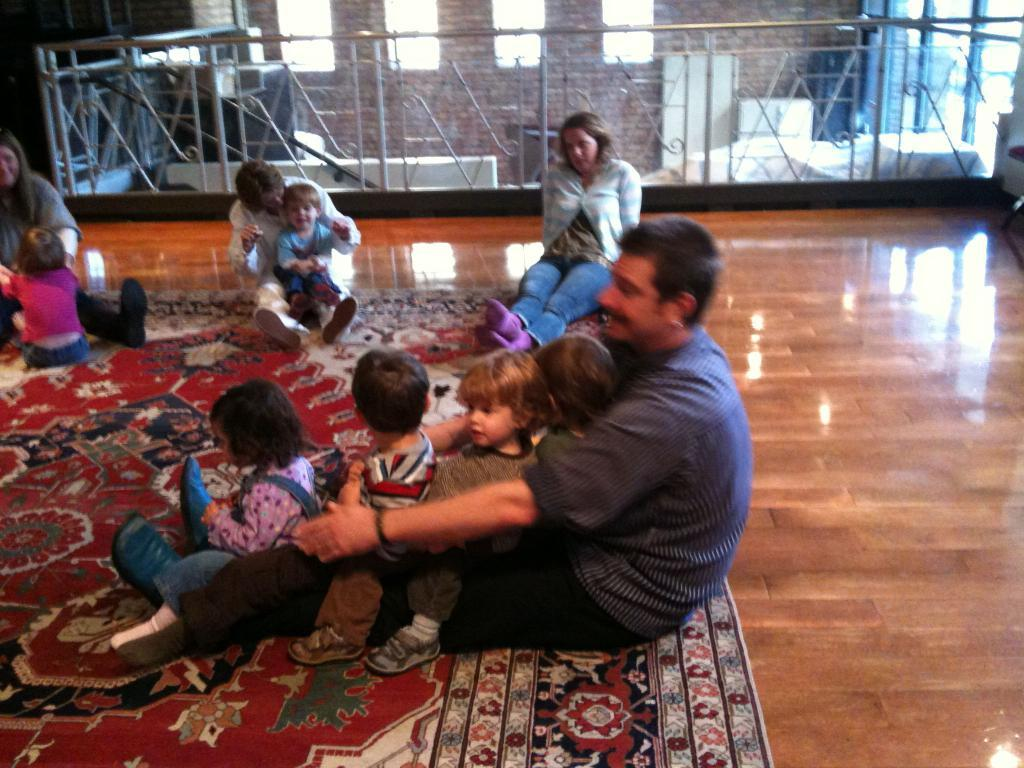What is on the floor in the image? There is a carpet on the floor in the image. What are the people in the image doing? The people are sitting on the carpet. What can be seen in the background of the image? There is a wall and a railing in the background of the image. What else is visible in the background of the image? There are objects visible in the background of the image. What type of juice is being served on the grass in the image? There is no juice or grass present in the image; it features a carpet with people sitting on it and a background with a wall and railing. 